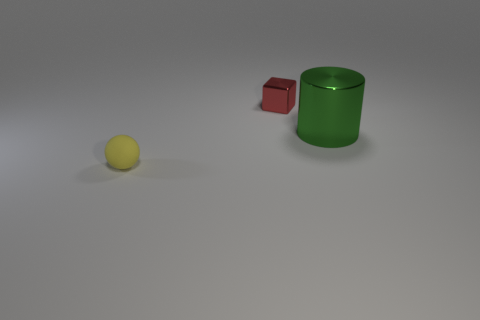What material is the small thing that is on the right side of the sphere that is in front of the big shiny thing?
Provide a succinct answer. Metal. What is the shape of the small red thing?
Make the answer very short. Cube. Are there an equal number of big green metallic things that are behind the cylinder and green cylinders that are behind the small red metal object?
Make the answer very short. Yes. There is a small object that is behind the rubber sphere; does it have the same color as the tiny object that is in front of the tiny red cube?
Your answer should be compact. No. Is the number of large green things to the right of the block greater than the number of cyan matte cylinders?
Give a very brief answer. Yes. There is a large object that is the same material as the cube; what shape is it?
Your answer should be very brief. Cylinder. Do the shiny thing to the right of the shiny cube and the ball have the same size?
Provide a short and direct response. No. What shape is the shiny thing right of the small thing that is to the right of the tiny sphere?
Your answer should be very brief. Cylinder. There is a metallic thing that is in front of the shiny object that is on the left side of the metallic cylinder; what size is it?
Offer a terse response. Large. What is the color of the object that is right of the small red metallic thing?
Ensure brevity in your answer.  Green. 